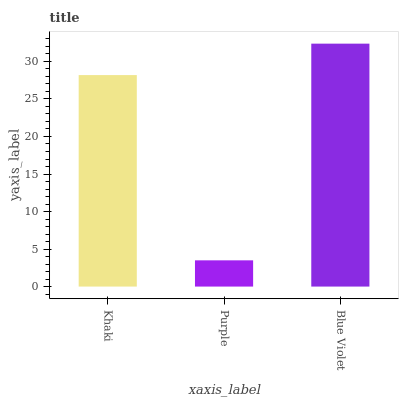Is Blue Violet the minimum?
Answer yes or no. No. Is Purple the maximum?
Answer yes or no. No. Is Blue Violet greater than Purple?
Answer yes or no. Yes. Is Purple less than Blue Violet?
Answer yes or no. Yes. Is Purple greater than Blue Violet?
Answer yes or no. No. Is Blue Violet less than Purple?
Answer yes or no. No. Is Khaki the high median?
Answer yes or no. Yes. Is Khaki the low median?
Answer yes or no. Yes. Is Purple the high median?
Answer yes or no. No. Is Purple the low median?
Answer yes or no. No. 